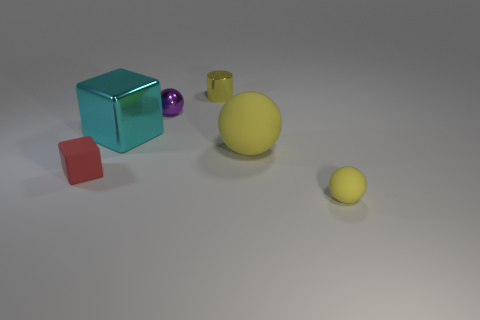Subtract all blue cylinders. How many yellow spheres are left? 2 Subtract all yellow matte spheres. How many spheres are left? 1 Add 3 tiny spheres. How many objects exist? 9 Subtract all cylinders. How many objects are left? 5 Add 6 cyan shiny things. How many cyan shiny things are left? 7 Add 1 big purple metal spheres. How many big purple metal spheres exist? 1 Subtract 1 cyan cubes. How many objects are left? 5 Subtract all small brown metallic things. Subtract all cyan shiny blocks. How many objects are left? 5 